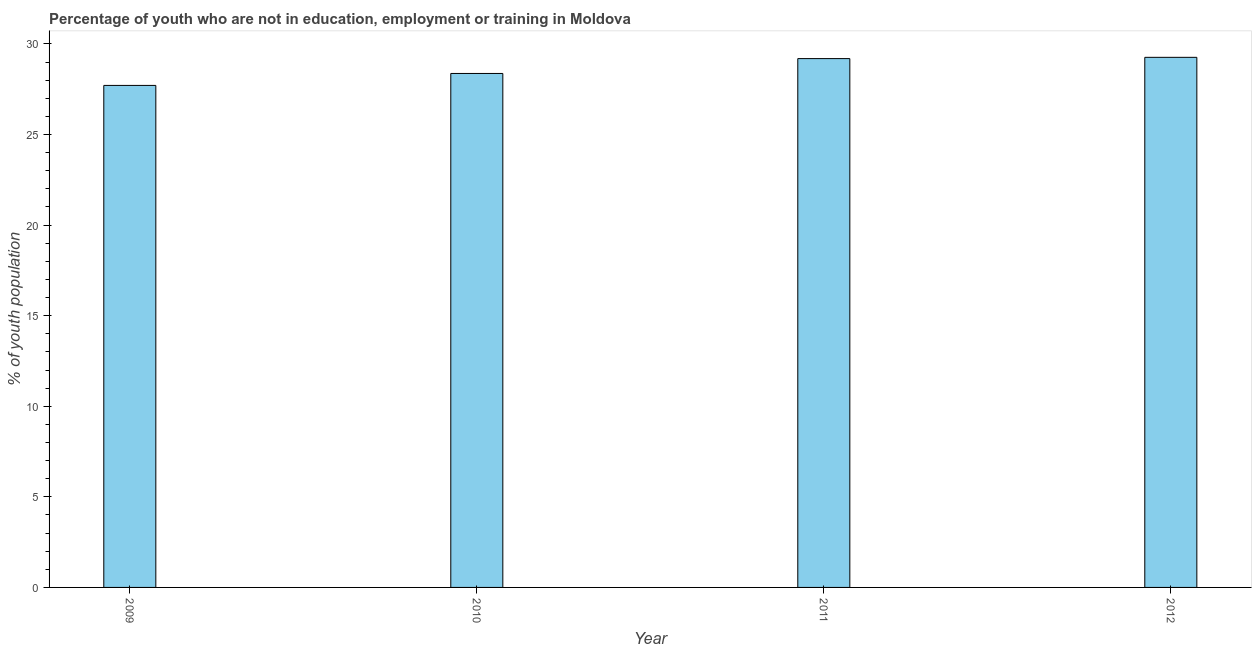What is the title of the graph?
Keep it short and to the point. Percentage of youth who are not in education, employment or training in Moldova. What is the label or title of the X-axis?
Offer a terse response. Year. What is the label or title of the Y-axis?
Ensure brevity in your answer.  % of youth population. What is the unemployed youth population in 2010?
Keep it short and to the point. 28.37. Across all years, what is the maximum unemployed youth population?
Ensure brevity in your answer.  29.26. Across all years, what is the minimum unemployed youth population?
Keep it short and to the point. 27.71. In which year was the unemployed youth population minimum?
Your answer should be compact. 2009. What is the sum of the unemployed youth population?
Make the answer very short. 114.53. What is the difference between the unemployed youth population in 2009 and 2012?
Your answer should be compact. -1.55. What is the average unemployed youth population per year?
Your answer should be very brief. 28.63. What is the median unemployed youth population?
Keep it short and to the point. 28.78. In how many years, is the unemployed youth population greater than 23 %?
Ensure brevity in your answer.  4. Do a majority of the years between 2010 and 2012 (inclusive) have unemployed youth population greater than 22 %?
Ensure brevity in your answer.  Yes. What is the ratio of the unemployed youth population in 2009 to that in 2012?
Provide a succinct answer. 0.95. Is the difference between the unemployed youth population in 2010 and 2011 greater than the difference between any two years?
Offer a very short reply. No. What is the difference between the highest and the second highest unemployed youth population?
Keep it short and to the point. 0.07. Is the sum of the unemployed youth population in 2010 and 2012 greater than the maximum unemployed youth population across all years?
Your response must be concise. Yes. What is the difference between the highest and the lowest unemployed youth population?
Ensure brevity in your answer.  1.55. How many bars are there?
Offer a very short reply. 4. Are all the bars in the graph horizontal?
Your answer should be very brief. No. How many years are there in the graph?
Offer a terse response. 4. What is the difference between two consecutive major ticks on the Y-axis?
Offer a very short reply. 5. What is the % of youth population in 2009?
Provide a succinct answer. 27.71. What is the % of youth population of 2010?
Give a very brief answer. 28.37. What is the % of youth population of 2011?
Offer a terse response. 29.19. What is the % of youth population of 2012?
Keep it short and to the point. 29.26. What is the difference between the % of youth population in 2009 and 2010?
Your answer should be very brief. -0.66. What is the difference between the % of youth population in 2009 and 2011?
Ensure brevity in your answer.  -1.48. What is the difference between the % of youth population in 2009 and 2012?
Your answer should be compact. -1.55. What is the difference between the % of youth population in 2010 and 2011?
Offer a very short reply. -0.82. What is the difference between the % of youth population in 2010 and 2012?
Keep it short and to the point. -0.89. What is the difference between the % of youth population in 2011 and 2012?
Your answer should be very brief. -0.07. What is the ratio of the % of youth population in 2009 to that in 2010?
Provide a succinct answer. 0.98. What is the ratio of the % of youth population in 2009 to that in 2011?
Provide a short and direct response. 0.95. What is the ratio of the % of youth population in 2009 to that in 2012?
Your answer should be very brief. 0.95. What is the ratio of the % of youth population in 2011 to that in 2012?
Provide a succinct answer. 1. 